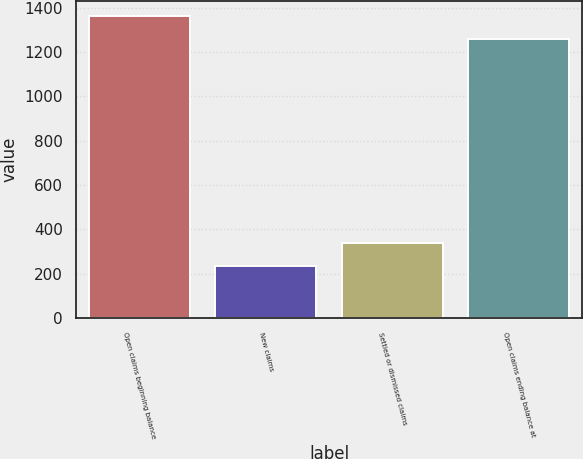Convert chart to OTSL. <chart><loc_0><loc_0><loc_500><loc_500><bar_chart><fcel>Open claims beginning balance<fcel>New claims<fcel>Settled or dismissed claims<fcel>Open claims ending balance at<nl><fcel>1363.8<fcel>233<fcel>338.8<fcel>1258<nl></chart> 